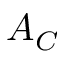Convert formula to latex. <formula><loc_0><loc_0><loc_500><loc_500>A _ { C }</formula> 